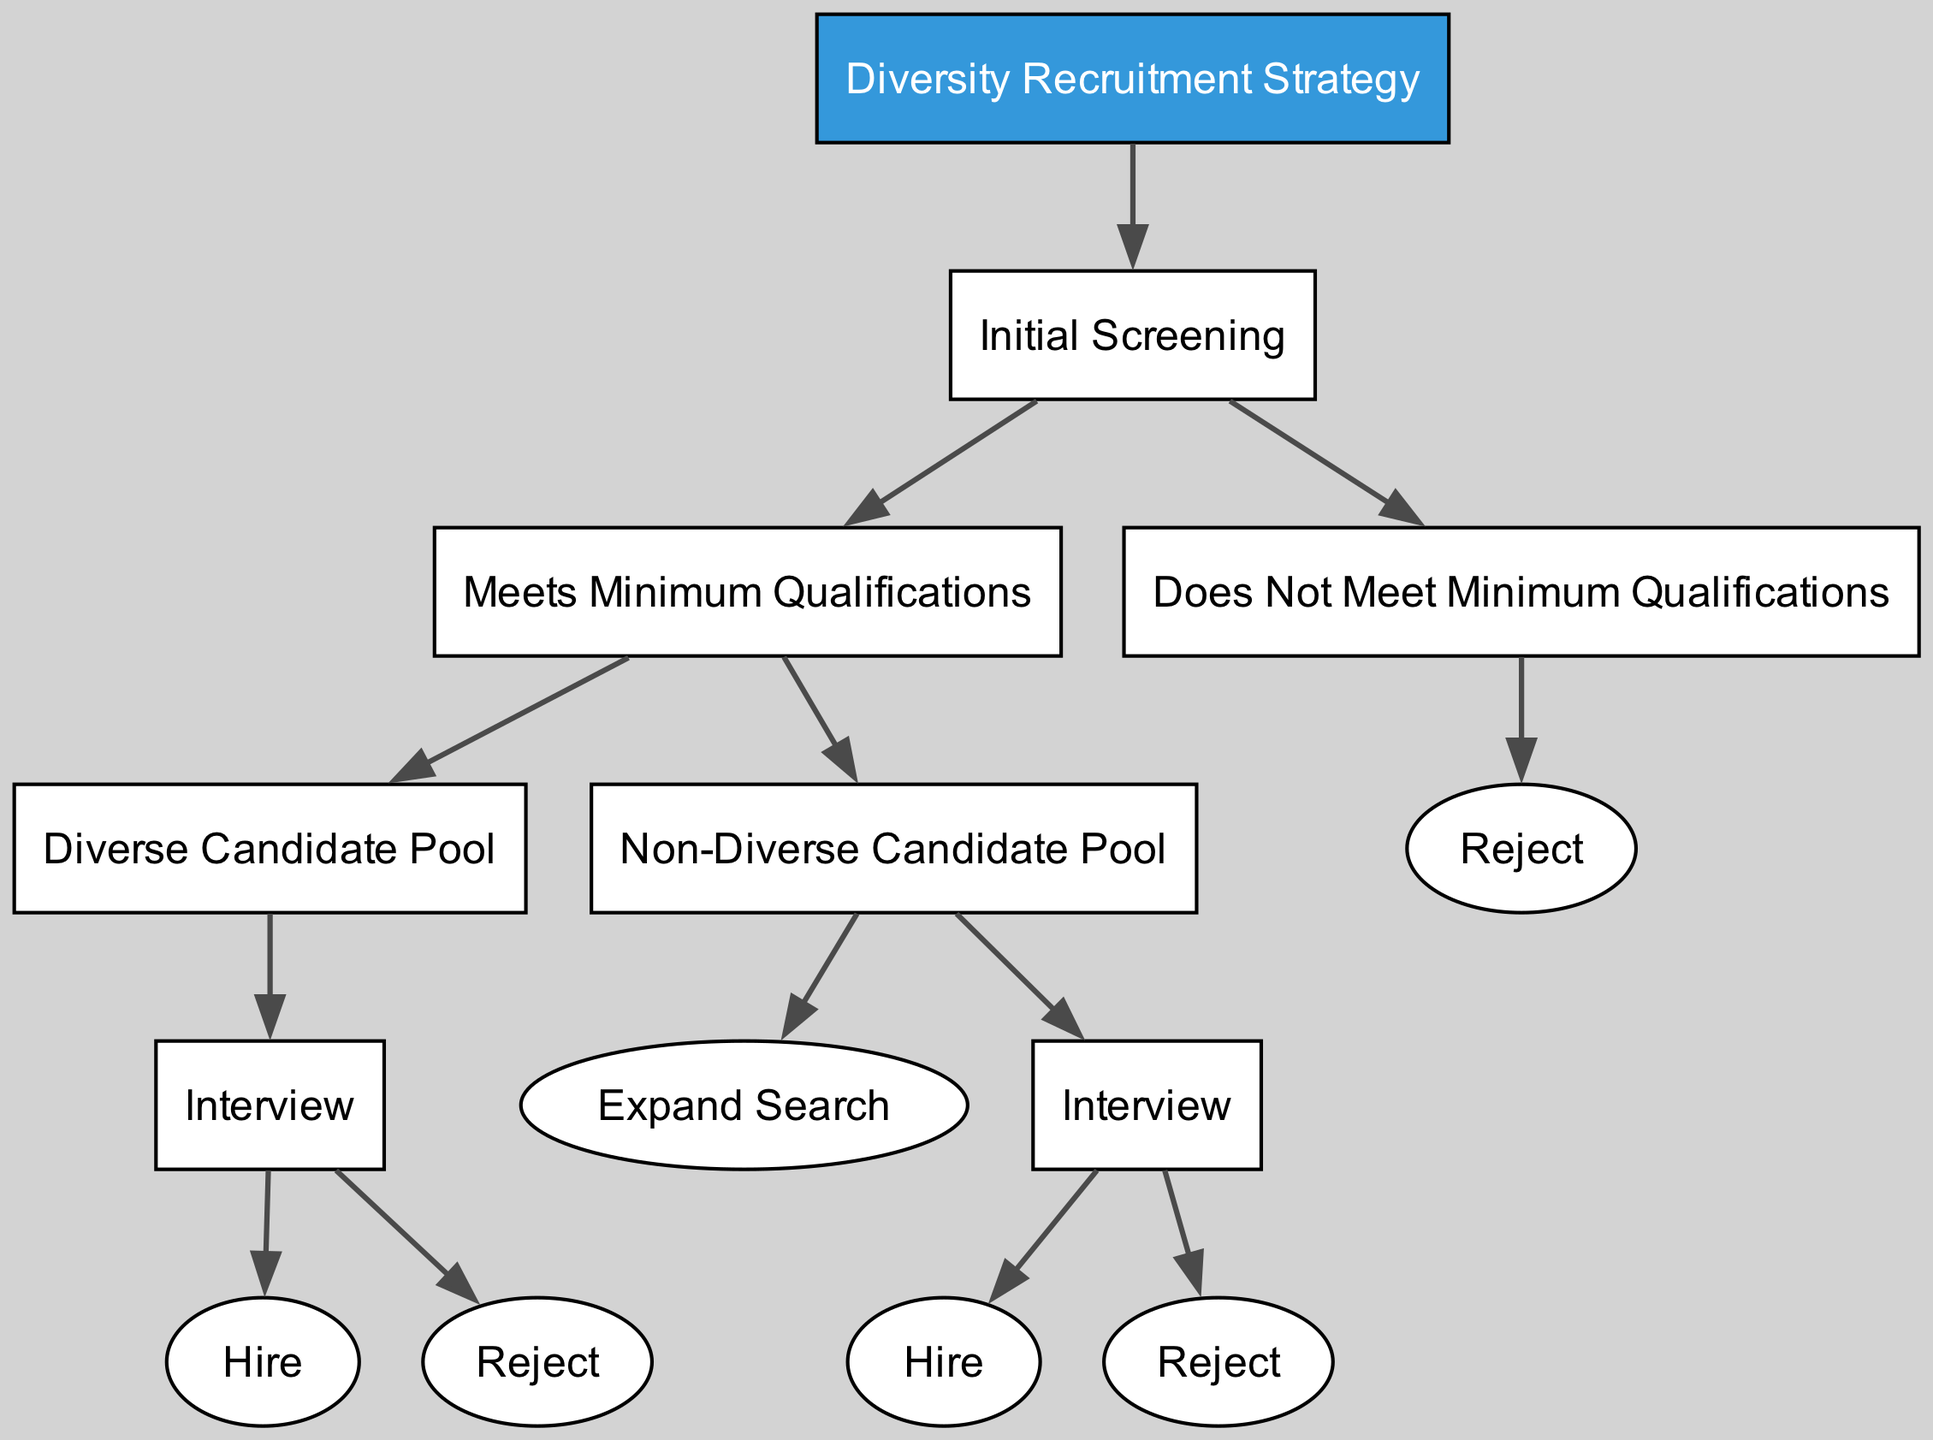What is the root of the decision tree? The root of the decision tree is the main starting point for decision-making, labeled as "Diversity Recruitment Strategy".
Answer: Diversity Recruitment Strategy How many initial screening outcomes are shown in the diagram? The diagram indicates two outcomes for the initial screening: "Meets Minimum Qualifications" and "Does Not Meet Minimum Qualifications".
Answer: Two What action follows a diverse candidate pool after meeting minimum qualifications? After confirming a diverse candidate pool, the next action is to conduct an "Interview".
Answer: Interview If a candidate does not meet the minimum qualifications, what is the resulting action? The immediate result of not meeting minimum qualifications is a direct "Reject".
Answer: Reject How does the process proceed if the candidate pool is non-diverse but meets qualifications? In this case, the process allows for either "Expand Search" or to proceed with an "Interview".
Answer: Expand Search or Interview What are the possible outcomes after conducting an interview for a non-diverse candidate pool? After interviewing a non-diverse candidate, the possible outcomes are either to "Hire" or "Reject" the candidate.
Answer: Hire or Reject How many children nodes does the "Meets Minimum Qualifications" node possess? The "Meets Minimum Qualifications" node has two children: "Diverse Candidate Pool" and "Non-Diverse Candidate Pool".
Answer: Two What is the next action after an interview if a non-diverse candidate is accepted? If the non-diverse candidate is accepted during the interview, the action following that is to "Hire".
Answer: Hire What happens when a candidate pool is diverse and interviews are conducted? When the candidate pool is diverse and interviews are conducted, the next steps are either to "Hire" or "Reject" after the interview.
Answer: Hire or Reject 